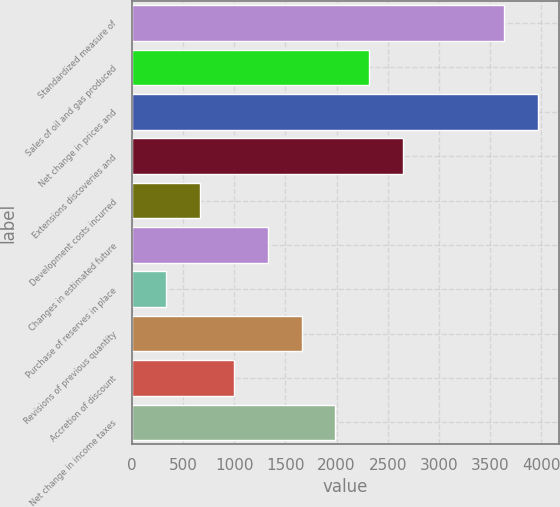Convert chart. <chart><loc_0><loc_0><loc_500><loc_500><bar_chart><fcel>Standardized measure of<fcel>Sales of oil and gas produced<fcel>Net change in prices and<fcel>Extensions discoveries and<fcel>Development costs incurred<fcel>Changes in estimated future<fcel>Purchase of reserves in place<fcel>Revisions of previous quantity<fcel>Accretion of discount<fcel>Net change in income taxes<nl><fcel>3640.5<fcel>2318.5<fcel>3971<fcel>2649<fcel>666<fcel>1327<fcel>335.5<fcel>1657.5<fcel>996.5<fcel>1988<nl></chart> 